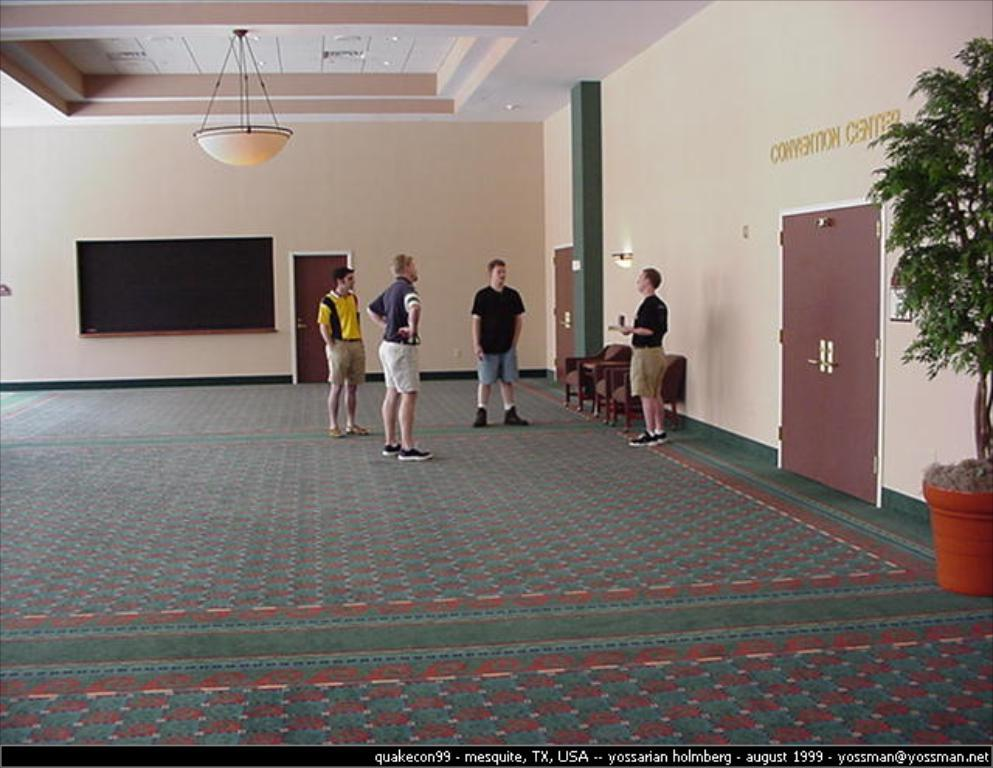How many people are present in the image? There are four people standing in the image. What type of surface is visible beneath the people? There is a floor in the image. What architectural features can be seen in the image? There are doors, walls, a screen, chairs, pillars, and a ceiling in the image. Is there any vegetation present in the image? Yes, there is a plant with a pot in the image. How many beds can be seen in the image? There are no beds visible in the image. What type of stretch is the plant performing in the image? The plant is not performing any stretch; it is stationary in its pot. 